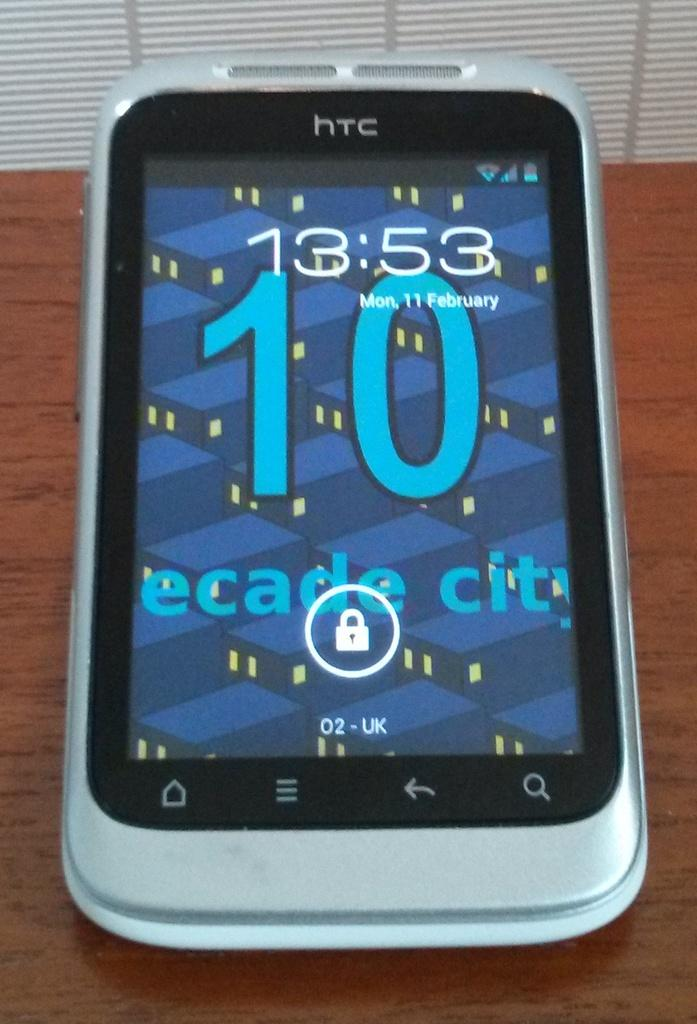<image>
Offer a succinct explanation of the picture presented. The phone on the table shows the date which is Monday, 11th February. 